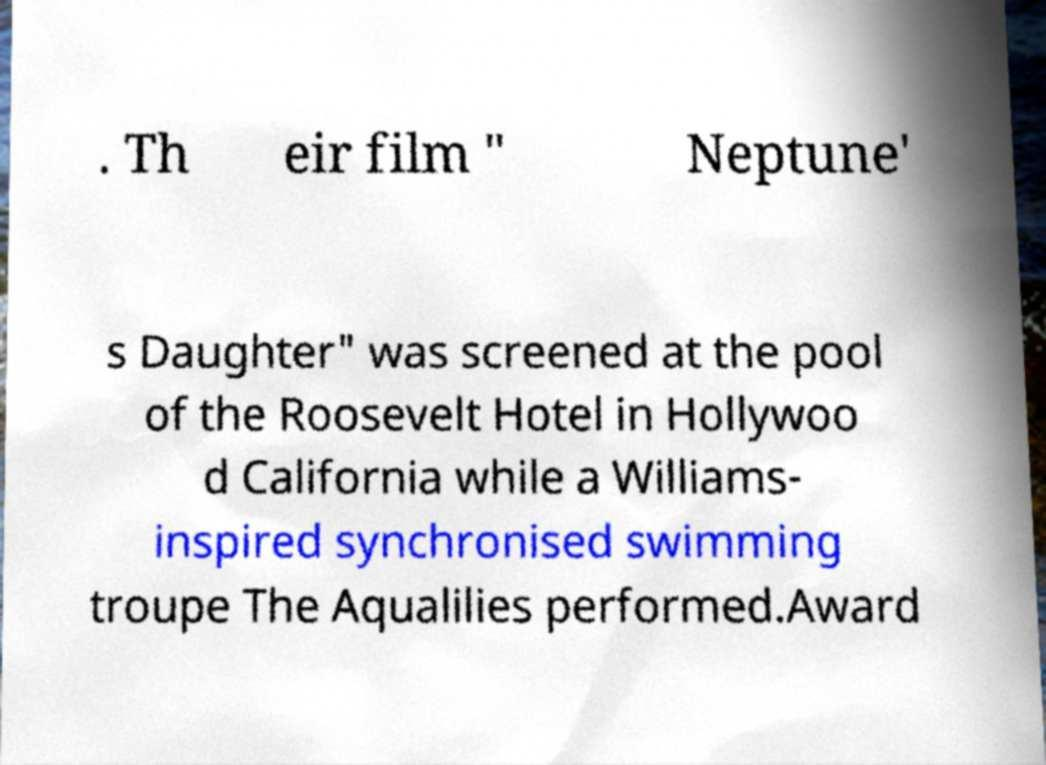Can you accurately transcribe the text from the provided image for me? . Th eir film " Neptune' s Daughter" was screened at the pool of the Roosevelt Hotel in Hollywoo d California while a Williams- inspired synchronised swimming troupe The Aqualilies performed.Award 